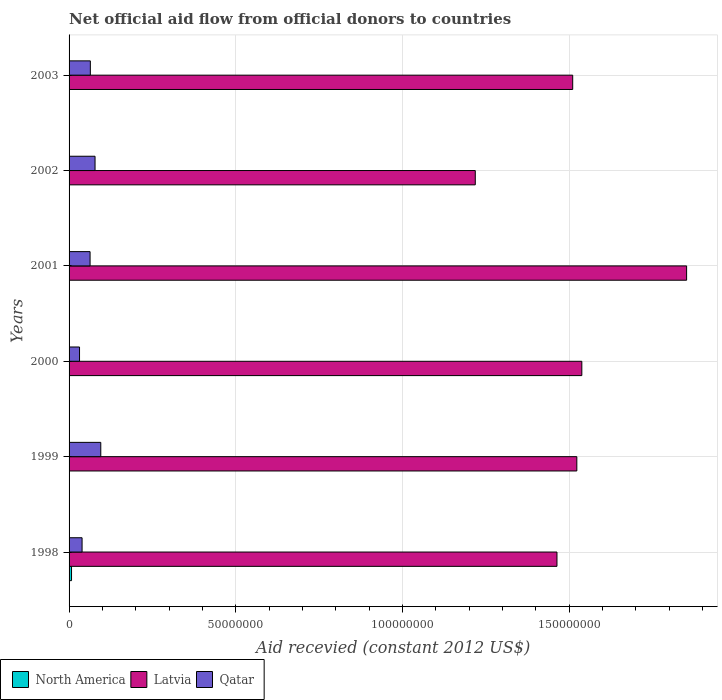How many different coloured bars are there?
Make the answer very short. 3. How many bars are there on the 5th tick from the bottom?
Give a very brief answer. 3. What is the total aid received in Qatar in 2002?
Make the answer very short. 7.79e+06. Across all years, what is the maximum total aid received in Latvia?
Your answer should be compact. 1.85e+08. In which year was the total aid received in North America maximum?
Keep it short and to the point. 1998. What is the total total aid received in Latvia in the graph?
Give a very brief answer. 9.11e+08. What is the difference between the total aid received in North America in 2001 and the total aid received in Qatar in 2002?
Make the answer very short. -7.75e+06. What is the average total aid received in North America per year?
Give a very brief answer. 1.82e+05. In the year 2000, what is the difference between the total aid received in Latvia and total aid received in Qatar?
Offer a terse response. 1.51e+08. Is the total aid received in Qatar in 1998 less than that in 2000?
Provide a short and direct response. No. What is the difference between the highest and the second highest total aid received in Qatar?
Offer a very short reply. 1.72e+06. What is the difference between the highest and the lowest total aid received in Qatar?
Your response must be concise. 6.37e+06. What does the 1st bar from the top in 1998 represents?
Ensure brevity in your answer.  Qatar. Are all the bars in the graph horizontal?
Your answer should be compact. Yes. How many years are there in the graph?
Your response must be concise. 6. What is the difference between two consecutive major ticks on the X-axis?
Ensure brevity in your answer.  5.00e+07. Are the values on the major ticks of X-axis written in scientific E-notation?
Provide a succinct answer. No. Does the graph contain any zero values?
Your answer should be compact. No. Does the graph contain grids?
Keep it short and to the point. Yes. How many legend labels are there?
Make the answer very short. 3. What is the title of the graph?
Ensure brevity in your answer.  Net official aid flow from official donors to countries. Does "Maldives" appear as one of the legend labels in the graph?
Offer a terse response. No. What is the label or title of the X-axis?
Give a very brief answer. Aid recevied (constant 2012 US$). What is the Aid recevied (constant 2012 US$) in North America in 1998?
Give a very brief answer. 7.40e+05. What is the Aid recevied (constant 2012 US$) in Latvia in 1998?
Keep it short and to the point. 1.46e+08. What is the Aid recevied (constant 2012 US$) in Qatar in 1998?
Make the answer very short. 3.90e+06. What is the Aid recevied (constant 2012 US$) in Latvia in 1999?
Give a very brief answer. 1.52e+08. What is the Aid recevied (constant 2012 US$) of Qatar in 1999?
Your answer should be very brief. 9.51e+06. What is the Aid recevied (constant 2012 US$) of Latvia in 2000?
Your answer should be very brief. 1.54e+08. What is the Aid recevied (constant 2012 US$) of Qatar in 2000?
Give a very brief answer. 3.14e+06. What is the Aid recevied (constant 2012 US$) in North America in 2001?
Offer a very short reply. 4.00e+04. What is the Aid recevied (constant 2012 US$) in Latvia in 2001?
Ensure brevity in your answer.  1.85e+08. What is the Aid recevied (constant 2012 US$) in Qatar in 2001?
Provide a succinct answer. 6.30e+06. What is the Aid recevied (constant 2012 US$) in North America in 2002?
Your response must be concise. 3.00e+04. What is the Aid recevied (constant 2012 US$) in Latvia in 2002?
Offer a terse response. 1.22e+08. What is the Aid recevied (constant 2012 US$) in Qatar in 2002?
Provide a succinct answer. 7.79e+06. What is the Aid recevied (constant 2012 US$) of Latvia in 2003?
Provide a short and direct response. 1.51e+08. What is the Aid recevied (constant 2012 US$) of Qatar in 2003?
Provide a short and direct response. 6.38e+06. Across all years, what is the maximum Aid recevied (constant 2012 US$) in North America?
Offer a very short reply. 7.40e+05. Across all years, what is the maximum Aid recevied (constant 2012 US$) in Latvia?
Your answer should be compact. 1.85e+08. Across all years, what is the maximum Aid recevied (constant 2012 US$) of Qatar?
Provide a succinct answer. 9.51e+06. Across all years, what is the minimum Aid recevied (constant 2012 US$) of Latvia?
Your answer should be very brief. 1.22e+08. Across all years, what is the minimum Aid recevied (constant 2012 US$) of Qatar?
Offer a very short reply. 3.14e+06. What is the total Aid recevied (constant 2012 US$) in North America in the graph?
Ensure brevity in your answer.  1.09e+06. What is the total Aid recevied (constant 2012 US$) of Latvia in the graph?
Ensure brevity in your answer.  9.11e+08. What is the total Aid recevied (constant 2012 US$) in Qatar in the graph?
Provide a short and direct response. 3.70e+07. What is the difference between the Aid recevied (constant 2012 US$) in Latvia in 1998 and that in 1999?
Give a very brief answer. -5.96e+06. What is the difference between the Aid recevied (constant 2012 US$) in Qatar in 1998 and that in 1999?
Your answer should be compact. -5.61e+06. What is the difference between the Aid recevied (constant 2012 US$) of North America in 1998 and that in 2000?
Offer a terse response. 6.30e+05. What is the difference between the Aid recevied (constant 2012 US$) of Latvia in 1998 and that in 2000?
Ensure brevity in your answer.  -7.46e+06. What is the difference between the Aid recevied (constant 2012 US$) of Qatar in 1998 and that in 2000?
Your answer should be very brief. 7.60e+05. What is the difference between the Aid recevied (constant 2012 US$) in Latvia in 1998 and that in 2001?
Your answer should be very brief. -3.89e+07. What is the difference between the Aid recevied (constant 2012 US$) of Qatar in 1998 and that in 2001?
Your response must be concise. -2.40e+06. What is the difference between the Aid recevied (constant 2012 US$) of North America in 1998 and that in 2002?
Your answer should be compact. 7.10e+05. What is the difference between the Aid recevied (constant 2012 US$) of Latvia in 1998 and that in 2002?
Your answer should be very brief. 2.45e+07. What is the difference between the Aid recevied (constant 2012 US$) of Qatar in 1998 and that in 2002?
Make the answer very short. -3.89e+06. What is the difference between the Aid recevied (constant 2012 US$) in Latvia in 1998 and that in 2003?
Offer a terse response. -4.72e+06. What is the difference between the Aid recevied (constant 2012 US$) in Qatar in 1998 and that in 2003?
Offer a terse response. -2.48e+06. What is the difference between the Aid recevied (constant 2012 US$) in Latvia in 1999 and that in 2000?
Keep it short and to the point. -1.50e+06. What is the difference between the Aid recevied (constant 2012 US$) in Qatar in 1999 and that in 2000?
Offer a terse response. 6.37e+06. What is the difference between the Aid recevied (constant 2012 US$) of North America in 1999 and that in 2001?
Your answer should be very brief. 9.00e+04. What is the difference between the Aid recevied (constant 2012 US$) of Latvia in 1999 and that in 2001?
Your answer should be compact. -3.29e+07. What is the difference between the Aid recevied (constant 2012 US$) in Qatar in 1999 and that in 2001?
Give a very brief answer. 3.21e+06. What is the difference between the Aid recevied (constant 2012 US$) in Latvia in 1999 and that in 2002?
Your answer should be very brief. 3.05e+07. What is the difference between the Aid recevied (constant 2012 US$) in Qatar in 1999 and that in 2002?
Provide a succinct answer. 1.72e+06. What is the difference between the Aid recevied (constant 2012 US$) in North America in 1999 and that in 2003?
Your answer should be very brief. 9.00e+04. What is the difference between the Aid recevied (constant 2012 US$) in Latvia in 1999 and that in 2003?
Give a very brief answer. 1.24e+06. What is the difference between the Aid recevied (constant 2012 US$) in Qatar in 1999 and that in 2003?
Ensure brevity in your answer.  3.13e+06. What is the difference between the Aid recevied (constant 2012 US$) of Latvia in 2000 and that in 2001?
Provide a short and direct response. -3.14e+07. What is the difference between the Aid recevied (constant 2012 US$) in Qatar in 2000 and that in 2001?
Keep it short and to the point. -3.16e+06. What is the difference between the Aid recevied (constant 2012 US$) in Latvia in 2000 and that in 2002?
Provide a succinct answer. 3.20e+07. What is the difference between the Aid recevied (constant 2012 US$) in Qatar in 2000 and that in 2002?
Offer a terse response. -4.65e+06. What is the difference between the Aid recevied (constant 2012 US$) of North America in 2000 and that in 2003?
Your answer should be very brief. 7.00e+04. What is the difference between the Aid recevied (constant 2012 US$) of Latvia in 2000 and that in 2003?
Keep it short and to the point. 2.74e+06. What is the difference between the Aid recevied (constant 2012 US$) of Qatar in 2000 and that in 2003?
Provide a short and direct response. -3.24e+06. What is the difference between the Aid recevied (constant 2012 US$) of Latvia in 2001 and that in 2002?
Provide a short and direct response. 6.34e+07. What is the difference between the Aid recevied (constant 2012 US$) of Qatar in 2001 and that in 2002?
Ensure brevity in your answer.  -1.49e+06. What is the difference between the Aid recevied (constant 2012 US$) in North America in 2001 and that in 2003?
Your response must be concise. 0. What is the difference between the Aid recevied (constant 2012 US$) in Latvia in 2001 and that in 2003?
Your answer should be very brief. 3.42e+07. What is the difference between the Aid recevied (constant 2012 US$) in Latvia in 2002 and that in 2003?
Provide a succinct answer. -2.92e+07. What is the difference between the Aid recevied (constant 2012 US$) of Qatar in 2002 and that in 2003?
Offer a very short reply. 1.41e+06. What is the difference between the Aid recevied (constant 2012 US$) of North America in 1998 and the Aid recevied (constant 2012 US$) of Latvia in 1999?
Your answer should be compact. -1.52e+08. What is the difference between the Aid recevied (constant 2012 US$) of North America in 1998 and the Aid recevied (constant 2012 US$) of Qatar in 1999?
Provide a succinct answer. -8.77e+06. What is the difference between the Aid recevied (constant 2012 US$) of Latvia in 1998 and the Aid recevied (constant 2012 US$) of Qatar in 1999?
Make the answer very short. 1.37e+08. What is the difference between the Aid recevied (constant 2012 US$) of North America in 1998 and the Aid recevied (constant 2012 US$) of Latvia in 2000?
Ensure brevity in your answer.  -1.53e+08. What is the difference between the Aid recevied (constant 2012 US$) in North America in 1998 and the Aid recevied (constant 2012 US$) in Qatar in 2000?
Offer a very short reply. -2.40e+06. What is the difference between the Aid recevied (constant 2012 US$) of Latvia in 1998 and the Aid recevied (constant 2012 US$) of Qatar in 2000?
Your answer should be compact. 1.43e+08. What is the difference between the Aid recevied (constant 2012 US$) in North America in 1998 and the Aid recevied (constant 2012 US$) in Latvia in 2001?
Offer a terse response. -1.84e+08. What is the difference between the Aid recevied (constant 2012 US$) of North America in 1998 and the Aid recevied (constant 2012 US$) of Qatar in 2001?
Provide a succinct answer. -5.56e+06. What is the difference between the Aid recevied (constant 2012 US$) of Latvia in 1998 and the Aid recevied (constant 2012 US$) of Qatar in 2001?
Provide a succinct answer. 1.40e+08. What is the difference between the Aid recevied (constant 2012 US$) in North America in 1998 and the Aid recevied (constant 2012 US$) in Latvia in 2002?
Make the answer very short. -1.21e+08. What is the difference between the Aid recevied (constant 2012 US$) in North America in 1998 and the Aid recevied (constant 2012 US$) in Qatar in 2002?
Give a very brief answer. -7.05e+06. What is the difference between the Aid recevied (constant 2012 US$) in Latvia in 1998 and the Aid recevied (constant 2012 US$) in Qatar in 2002?
Make the answer very short. 1.39e+08. What is the difference between the Aid recevied (constant 2012 US$) of North America in 1998 and the Aid recevied (constant 2012 US$) of Latvia in 2003?
Offer a terse response. -1.50e+08. What is the difference between the Aid recevied (constant 2012 US$) of North America in 1998 and the Aid recevied (constant 2012 US$) of Qatar in 2003?
Offer a terse response. -5.64e+06. What is the difference between the Aid recevied (constant 2012 US$) in Latvia in 1998 and the Aid recevied (constant 2012 US$) in Qatar in 2003?
Ensure brevity in your answer.  1.40e+08. What is the difference between the Aid recevied (constant 2012 US$) of North America in 1999 and the Aid recevied (constant 2012 US$) of Latvia in 2000?
Give a very brief answer. -1.54e+08. What is the difference between the Aid recevied (constant 2012 US$) in North America in 1999 and the Aid recevied (constant 2012 US$) in Qatar in 2000?
Your response must be concise. -3.01e+06. What is the difference between the Aid recevied (constant 2012 US$) of Latvia in 1999 and the Aid recevied (constant 2012 US$) of Qatar in 2000?
Your answer should be compact. 1.49e+08. What is the difference between the Aid recevied (constant 2012 US$) of North America in 1999 and the Aid recevied (constant 2012 US$) of Latvia in 2001?
Your answer should be very brief. -1.85e+08. What is the difference between the Aid recevied (constant 2012 US$) of North America in 1999 and the Aid recevied (constant 2012 US$) of Qatar in 2001?
Offer a very short reply. -6.17e+06. What is the difference between the Aid recevied (constant 2012 US$) in Latvia in 1999 and the Aid recevied (constant 2012 US$) in Qatar in 2001?
Your answer should be compact. 1.46e+08. What is the difference between the Aid recevied (constant 2012 US$) of North America in 1999 and the Aid recevied (constant 2012 US$) of Latvia in 2002?
Offer a terse response. -1.22e+08. What is the difference between the Aid recevied (constant 2012 US$) in North America in 1999 and the Aid recevied (constant 2012 US$) in Qatar in 2002?
Your response must be concise. -7.66e+06. What is the difference between the Aid recevied (constant 2012 US$) of Latvia in 1999 and the Aid recevied (constant 2012 US$) of Qatar in 2002?
Keep it short and to the point. 1.45e+08. What is the difference between the Aid recevied (constant 2012 US$) in North America in 1999 and the Aid recevied (constant 2012 US$) in Latvia in 2003?
Your answer should be compact. -1.51e+08. What is the difference between the Aid recevied (constant 2012 US$) in North America in 1999 and the Aid recevied (constant 2012 US$) in Qatar in 2003?
Provide a short and direct response. -6.25e+06. What is the difference between the Aid recevied (constant 2012 US$) of Latvia in 1999 and the Aid recevied (constant 2012 US$) of Qatar in 2003?
Your answer should be compact. 1.46e+08. What is the difference between the Aid recevied (constant 2012 US$) of North America in 2000 and the Aid recevied (constant 2012 US$) of Latvia in 2001?
Your answer should be compact. -1.85e+08. What is the difference between the Aid recevied (constant 2012 US$) of North America in 2000 and the Aid recevied (constant 2012 US$) of Qatar in 2001?
Keep it short and to the point. -6.19e+06. What is the difference between the Aid recevied (constant 2012 US$) of Latvia in 2000 and the Aid recevied (constant 2012 US$) of Qatar in 2001?
Give a very brief answer. 1.48e+08. What is the difference between the Aid recevied (constant 2012 US$) in North America in 2000 and the Aid recevied (constant 2012 US$) in Latvia in 2002?
Provide a succinct answer. -1.22e+08. What is the difference between the Aid recevied (constant 2012 US$) in North America in 2000 and the Aid recevied (constant 2012 US$) in Qatar in 2002?
Offer a terse response. -7.68e+06. What is the difference between the Aid recevied (constant 2012 US$) of Latvia in 2000 and the Aid recevied (constant 2012 US$) of Qatar in 2002?
Give a very brief answer. 1.46e+08. What is the difference between the Aid recevied (constant 2012 US$) in North America in 2000 and the Aid recevied (constant 2012 US$) in Latvia in 2003?
Provide a succinct answer. -1.51e+08. What is the difference between the Aid recevied (constant 2012 US$) in North America in 2000 and the Aid recevied (constant 2012 US$) in Qatar in 2003?
Give a very brief answer. -6.27e+06. What is the difference between the Aid recevied (constant 2012 US$) in Latvia in 2000 and the Aid recevied (constant 2012 US$) in Qatar in 2003?
Your answer should be very brief. 1.47e+08. What is the difference between the Aid recevied (constant 2012 US$) in North America in 2001 and the Aid recevied (constant 2012 US$) in Latvia in 2002?
Provide a succinct answer. -1.22e+08. What is the difference between the Aid recevied (constant 2012 US$) of North America in 2001 and the Aid recevied (constant 2012 US$) of Qatar in 2002?
Your response must be concise. -7.75e+06. What is the difference between the Aid recevied (constant 2012 US$) in Latvia in 2001 and the Aid recevied (constant 2012 US$) in Qatar in 2002?
Provide a succinct answer. 1.77e+08. What is the difference between the Aid recevied (constant 2012 US$) in North America in 2001 and the Aid recevied (constant 2012 US$) in Latvia in 2003?
Give a very brief answer. -1.51e+08. What is the difference between the Aid recevied (constant 2012 US$) in North America in 2001 and the Aid recevied (constant 2012 US$) in Qatar in 2003?
Provide a succinct answer. -6.34e+06. What is the difference between the Aid recevied (constant 2012 US$) in Latvia in 2001 and the Aid recevied (constant 2012 US$) in Qatar in 2003?
Give a very brief answer. 1.79e+08. What is the difference between the Aid recevied (constant 2012 US$) of North America in 2002 and the Aid recevied (constant 2012 US$) of Latvia in 2003?
Your response must be concise. -1.51e+08. What is the difference between the Aid recevied (constant 2012 US$) in North America in 2002 and the Aid recevied (constant 2012 US$) in Qatar in 2003?
Ensure brevity in your answer.  -6.35e+06. What is the difference between the Aid recevied (constant 2012 US$) in Latvia in 2002 and the Aid recevied (constant 2012 US$) in Qatar in 2003?
Give a very brief answer. 1.15e+08. What is the average Aid recevied (constant 2012 US$) of North America per year?
Offer a very short reply. 1.82e+05. What is the average Aid recevied (constant 2012 US$) of Latvia per year?
Provide a succinct answer. 1.52e+08. What is the average Aid recevied (constant 2012 US$) of Qatar per year?
Give a very brief answer. 6.17e+06. In the year 1998, what is the difference between the Aid recevied (constant 2012 US$) in North America and Aid recevied (constant 2012 US$) in Latvia?
Your answer should be very brief. -1.46e+08. In the year 1998, what is the difference between the Aid recevied (constant 2012 US$) of North America and Aid recevied (constant 2012 US$) of Qatar?
Make the answer very short. -3.16e+06. In the year 1998, what is the difference between the Aid recevied (constant 2012 US$) of Latvia and Aid recevied (constant 2012 US$) of Qatar?
Your answer should be very brief. 1.42e+08. In the year 1999, what is the difference between the Aid recevied (constant 2012 US$) in North America and Aid recevied (constant 2012 US$) in Latvia?
Ensure brevity in your answer.  -1.52e+08. In the year 1999, what is the difference between the Aid recevied (constant 2012 US$) in North America and Aid recevied (constant 2012 US$) in Qatar?
Offer a very short reply. -9.38e+06. In the year 1999, what is the difference between the Aid recevied (constant 2012 US$) of Latvia and Aid recevied (constant 2012 US$) of Qatar?
Keep it short and to the point. 1.43e+08. In the year 2000, what is the difference between the Aid recevied (constant 2012 US$) of North America and Aid recevied (constant 2012 US$) of Latvia?
Provide a succinct answer. -1.54e+08. In the year 2000, what is the difference between the Aid recevied (constant 2012 US$) in North America and Aid recevied (constant 2012 US$) in Qatar?
Make the answer very short. -3.03e+06. In the year 2000, what is the difference between the Aid recevied (constant 2012 US$) of Latvia and Aid recevied (constant 2012 US$) of Qatar?
Ensure brevity in your answer.  1.51e+08. In the year 2001, what is the difference between the Aid recevied (constant 2012 US$) of North America and Aid recevied (constant 2012 US$) of Latvia?
Provide a succinct answer. -1.85e+08. In the year 2001, what is the difference between the Aid recevied (constant 2012 US$) of North America and Aid recevied (constant 2012 US$) of Qatar?
Ensure brevity in your answer.  -6.26e+06. In the year 2001, what is the difference between the Aid recevied (constant 2012 US$) in Latvia and Aid recevied (constant 2012 US$) in Qatar?
Your answer should be compact. 1.79e+08. In the year 2002, what is the difference between the Aid recevied (constant 2012 US$) of North America and Aid recevied (constant 2012 US$) of Latvia?
Offer a very short reply. -1.22e+08. In the year 2002, what is the difference between the Aid recevied (constant 2012 US$) of North America and Aid recevied (constant 2012 US$) of Qatar?
Offer a very short reply. -7.76e+06. In the year 2002, what is the difference between the Aid recevied (constant 2012 US$) in Latvia and Aid recevied (constant 2012 US$) in Qatar?
Make the answer very short. 1.14e+08. In the year 2003, what is the difference between the Aid recevied (constant 2012 US$) of North America and Aid recevied (constant 2012 US$) of Latvia?
Your answer should be very brief. -1.51e+08. In the year 2003, what is the difference between the Aid recevied (constant 2012 US$) of North America and Aid recevied (constant 2012 US$) of Qatar?
Ensure brevity in your answer.  -6.34e+06. In the year 2003, what is the difference between the Aid recevied (constant 2012 US$) of Latvia and Aid recevied (constant 2012 US$) of Qatar?
Make the answer very short. 1.45e+08. What is the ratio of the Aid recevied (constant 2012 US$) in North America in 1998 to that in 1999?
Your answer should be very brief. 5.69. What is the ratio of the Aid recevied (constant 2012 US$) in Latvia in 1998 to that in 1999?
Your answer should be compact. 0.96. What is the ratio of the Aid recevied (constant 2012 US$) in Qatar in 1998 to that in 1999?
Provide a short and direct response. 0.41. What is the ratio of the Aid recevied (constant 2012 US$) of North America in 1998 to that in 2000?
Keep it short and to the point. 6.73. What is the ratio of the Aid recevied (constant 2012 US$) of Latvia in 1998 to that in 2000?
Your answer should be compact. 0.95. What is the ratio of the Aid recevied (constant 2012 US$) in Qatar in 1998 to that in 2000?
Keep it short and to the point. 1.24. What is the ratio of the Aid recevied (constant 2012 US$) in Latvia in 1998 to that in 2001?
Your answer should be compact. 0.79. What is the ratio of the Aid recevied (constant 2012 US$) of Qatar in 1998 to that in 2001?
Provide a succinct answer. 0.62. What is the ratio of the Aid recevied (constant 2012 US$) in North America in 1998 to that in 2002?
Provide a succinct answer. 24.67. What is the ratio of the Aid recevied (constant 2012 US$) in Latvia in 1998 to that in 2002?
Provide a succinct answer. 1.2. What is the ratio of the Aid recevied (constant 2012 US$) in Qatar in 1998 to that in 2002?
Provide a succinct answer. 0.5. What is the ratio of the Aid recevied (constant 2012 US$) in North America in 1998 to that in 2003?
Provide a short and direct response. 18.5. What is the ratio of the Aid recevied (constant 2012 US$) of Latvia in 1998 to that in 2003?
Make the answer very short. 0.97. What is the ratio of the Aid recevied (constant 2012 US$) in Qatar in 1998 to that in 2003?
Provide a succinct answer. 0.61. What is the ratio of the Aid recevied (constant 2012 US$) in North America in 1999 to that in 2000?
Offer a very short reply. 1.18. What is the ratio of the Aid recevied (constant 2012 US$) of Latvia in 1999 to that in 2000?
Provide a succinct answer. 0.99. What is the ratio of the Aid recevied (constant 2012 US$) of Qatar in 1999 to that in 2000?
Keep it short and to the point. 3.03. What is the ratio of the Aid recevied (constant 2012 US$) of Latvia in 1999 to that in 2001?
Keep it short and to the point. 0.82. What is the ratio of the Aid recevied (constant 2012 US$) in Qatar in 1999 to that in 2001?
Your response must be concise. 1.51. What is the ratio of the Aid recevied (constant 2012 US$) of North America in 1999 to that in 2002?
Your response must be concise. 4.33. What is the ratio of the Aid recevied (constant 2012 US$) in Qatar in 1999 to that in 2002?
Provide a short and direct response. 1.22. What is the ratio of the Aid recevied (constant 2012 US$) in Latvia in 1999 to that in 2003?
Offer a very short reply. 1.01. What is the ratio of the Aid recevied (constant 2012 US$) of Qatar in 1999 to that in 2003?
Offer a very short reply. 1.49. What is the ratio of the Aid recevied (constant 2012 US$) of North America in 2000 to that in 2001?
Provide a succinct answer. 2.75. What is the ratio of the Aid recevied (constant 2012 US$) of Latvia in 2000 to that in 2001?
Your answer should be very brief. 0.83. What is the ratio of the Aid recevied (constant 2012 US$) of Qatar in 2000 to that in 2001?
Your answer should be very brief. 0.5. What is the ratio of the Aid recevied (constant 2012 US$) of North America in 2000 to that in 2002?
Offer a very short reply. 3.67. What is the ratio of the Aid recevied (constant 2012 US$) in Latvia in 2000 to that in 2002?
Provide a short and direct response. 1.26. What is the ratio of the Aid recevied (constant 2012 US$) in Qatar in 2000 to that in 2002?
Your response must be concise. 0.4. What is the ratio of the Aid recevied (constant 2012 US$) in North America in 2000 to that in 2003?
Your response must be concise. 2.75. What is the ratio of the Aid recevied (constant 2012 US$) of Latvia in 2000 to that in 2003?
Your response must be concise. 1.02. What is the ratio of the Aid recevied (constant 2012 US$) in Qatar in 2000 to that in 2003?
Keep it short and to the point. 0.49. What is the ratio of the Aid recevied (constant 2012 US$) of North America in 2001 to that in 2002?
Provide a short and direct response. 1.33. What is the ratio of the Aid recevied (constant 2012 US$) of Latvia in 2001 to that in 2002?
Keep it short and to the point. 1.52. What is the ratio of the Aid recevied (constant 2012 US$) of Qatar in 2001 to that in 2002?
Ensure brevity in your answer.  0.81. What is the ratio of the Aid recevied (constant 2012 US$) of Latvia in 2001 to that in 2003?
Ensure brevity in your answer.  1.23. What is the ratio of the Aid recevied (constant 2012 US$) in Qatar in 2001 to that in 2003?
Provide a short and direct response. 0.99. What is the ratio of the Aid recevied (constant 2012 US$) of Latvia in 2002 to that in 2003?
Keep it short and to the point. 0.81. What is the ratio of the Aid recevied (constant 2012 US$) in Qatar in 2002 to that in 2003?
Provide a succinct answer. 1.22. What is the difference between the highest and the second highest Aid recevied (constant 2012 US$) in Latvia?
Offer a terse response. 3.14e+07. What is the difference between the highest and the second highest Aid recevied (constant 2012 US$) in Qatar?
Offer a very short reply. 1.72e+06. What is the difference between the highest and the lowest Aid recevied (constant 2012 US$) of North America?
Your answer should be very brief. 7.10e+05. What is the difference between the highest and the lowest Aid recevied (constant 2012 US$) of Latvia?
Your answer should be compact. 6.34e+07. What is the difference between the highest and the lowest Aid recevied (constant 2012 US$) of Qatar?
Keep it short and to the point. 6.37e+06. 